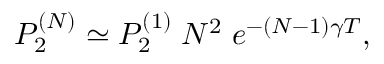Convert formula to latex. <formula><loc_0><loc_0><loc_500><loc_500>P _ { 2 } ^ { ( N ) } \simeq P _ { 2 } ^ { ( 1 ) } \, N ^ { 2 } \, e ^ { - ( N - 1 ) \gamma T } ,</formula> 